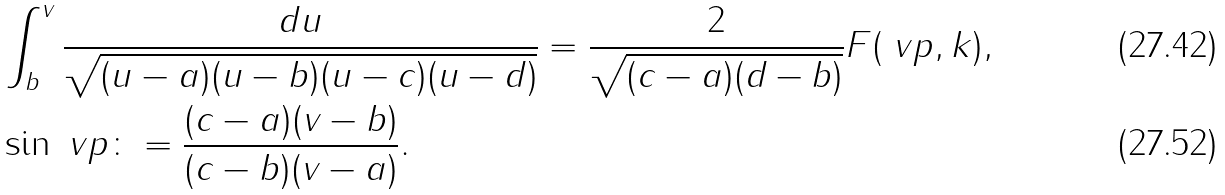Convert formula to latex. <formula><loc_0><loc_0><loc_500><loc_500>& \int _ { b } ^ { v } \frac { d u } { \sqrt { ( u - a ) ( u - b ) ( u - c ) ( u - d ) } } = \frac { 2 } { \sqrt { ( c - a ) ( d - b ) } } F ( \ v p , k ) , \\ & \sin \ v p \colon = \frac { ( c - a ) ( v - b ) } { ( c - b ) ( v - a ) } .</formula> 